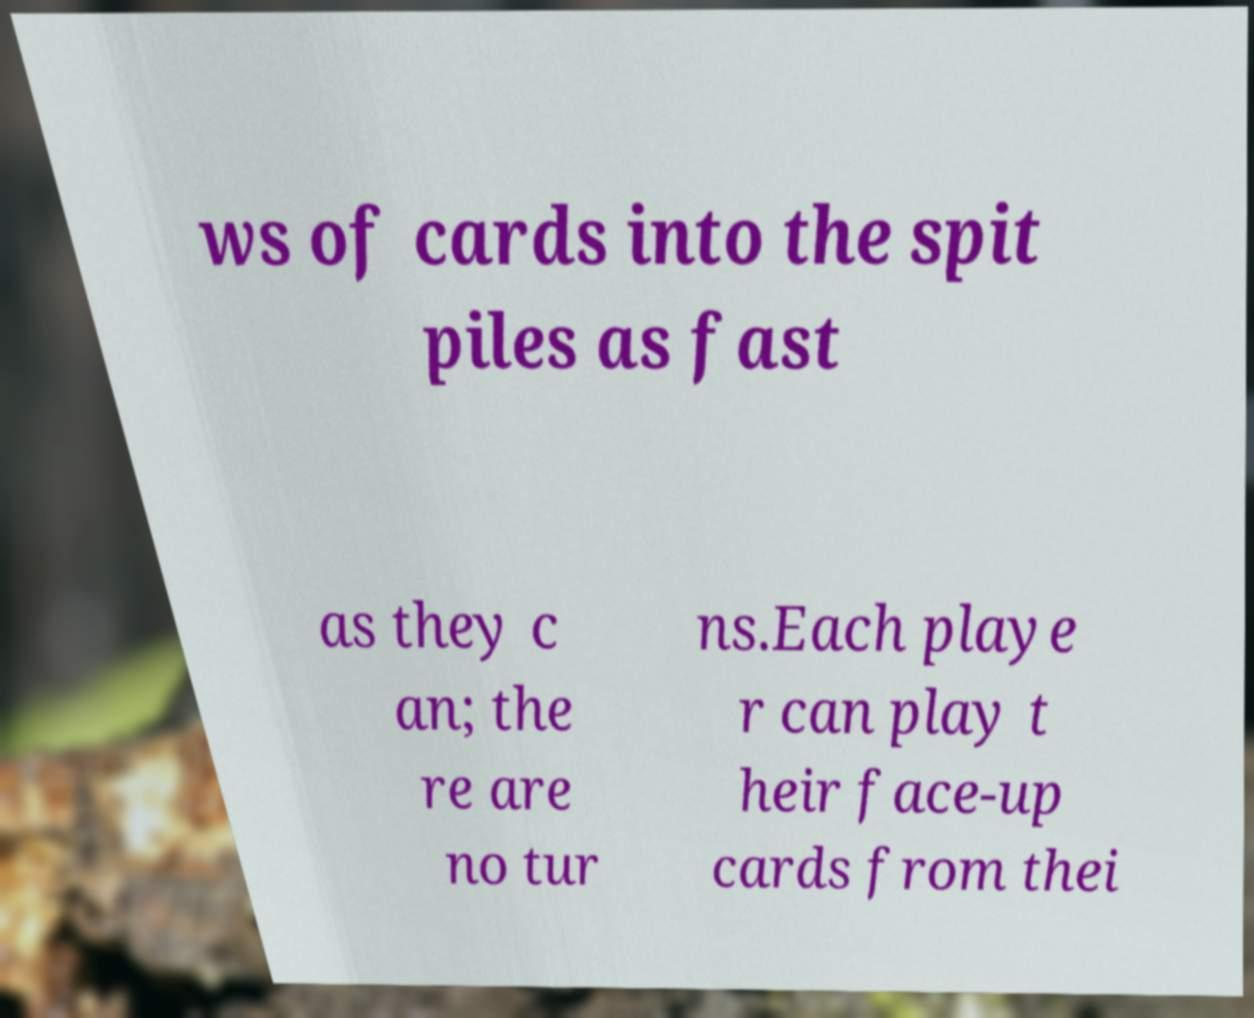Please read and relay the text visible in this image. What does it say? ws of cards into the spit piles as fast as they c an; the re are no tur ns.Each playe r can play t heir face-up cards from thei 